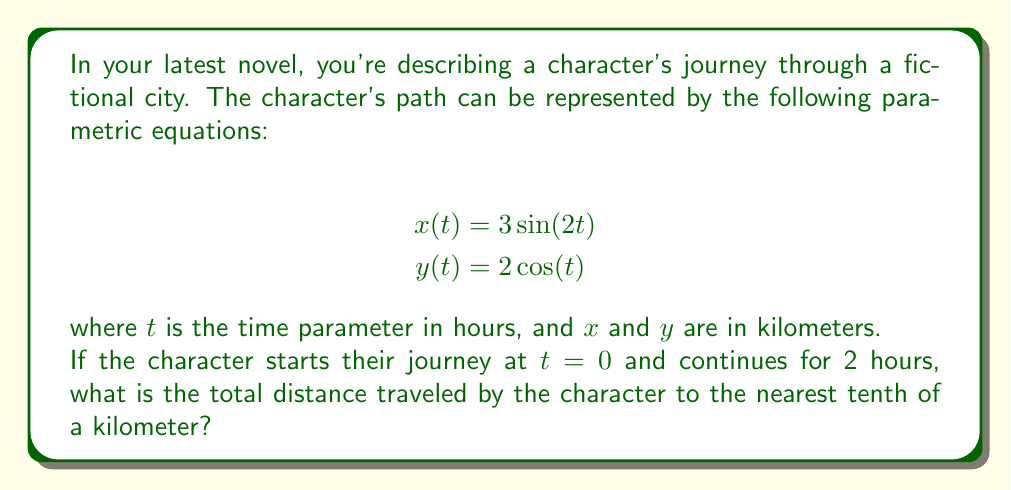Solve this math problem. To solve this problem, we need to follow these steps:

1) The distance traveled along a parametric curve is given by the arc length formula:

   $$L = \int_{a}^{b} \sqrt{\left(\frac{dx}{dt}\right)^2 + \left(\frac{dy}{dt}\right)^2} dt$$

2) First, we need to find $\frac{dx}{dt}$ and $\frac{dy}{dt}$:
   
   $$\frac{dx}{dt} = 6\cos(2t)$$
   $$\frac{dy}{dt} = -2\sin(t)$$

3) Now, we can substitute these into our arc length formula:

   $$L = \int_{0}^{2} \sqrt{(6\cos(2t))^2 + (-2\sin(t))^2} dt$$

4) Simplify under the square root:

   $$L = \int_{0}^{2} \sqrt{36\cos^2(2t) + 4\sin^2(t)} dt$$

5) This integral cannot be solved analytically, so we need to use numerical integration. We can use a computer algebra system or a graphing calculator to evaluate this integral.

6) Using a numerical integration method (like Simpson's rule or the trapezoidal rule), we get:

   $$L \approx 13.4519...$$

7) Rounding to the nearest tenth, we get 13.5 kilometers.
Answer: 13.5 kilometers 